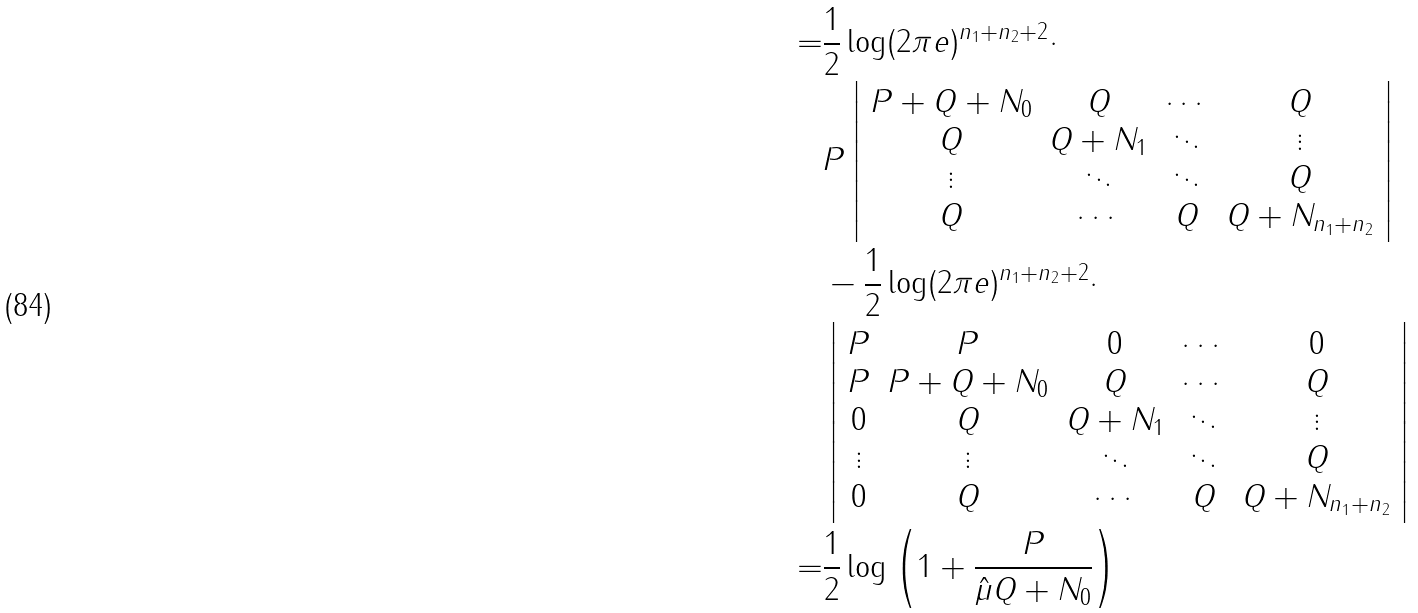Convert formula to latex. <formula><loc_0><loc_0><loc_500><loc_500>= & \frac { 1 } { 2 } \log ( 2 \pi e ) ^ { n _ { 1 } + n _ { 2 } + 2 } \cdot \\ & P \left | \begin{array} { c c c c } P + Q + N _ { 0 } & Q & \cdots & Q \\ Q & Q + N _ { 1 } & \ddots & \vdots \\ \vdots & \ddots & \ddots & Q \\ Q & \cdots & Q & Q + N _ { n _ { 1 } + n _ { 2 } } \end{array} \right | \\ & - \frac { 1 } { 2 } \log ( 2 \pi e ) ^ { n _ { 1 } + n _ { 2 } + 2 } \cdot \\ & \left | \begin{array} { c c c c c } P & P & 0 & \cdots & 0 \\ P & P + Q + N _ { 0 } & Q & \cdots & Q \\ 0 & Q & Q + N _ { 1 } & \ddots & \vdots \\ \vdots & \vdots & \ddots & \ddots & Q \\ 0 & Q & \cdots & Q & Q + N _ { n _ { 1 } + n _ { 2 } } \end{array} \right | \\ = & \frac { 1 } { 2 } \log \left ( 1 + \frac { P } { \hat { \mu } Q + N _ { 0 } } \right )</formula> 